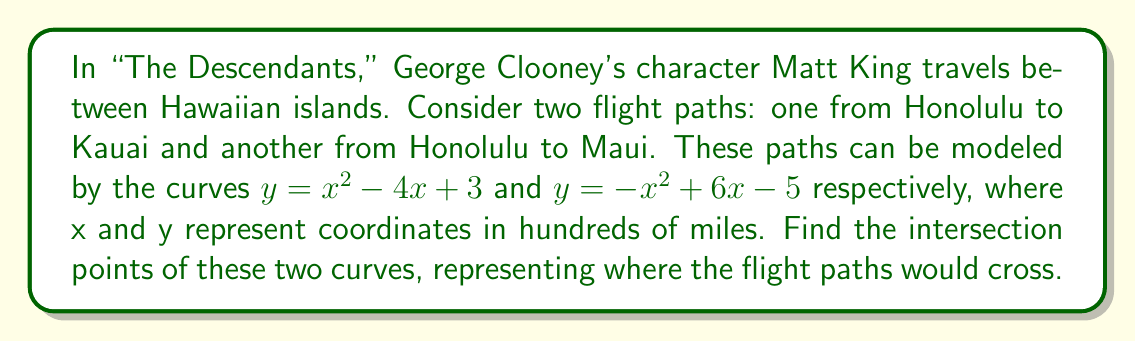Solve this math problem. 1) To find the intersection points, we need to solve the equation:
   $x^2 - 4x + 3 = -x^2 + 6x - 5$

2) Rearranging the equation:
   $x^2 - 4x + 3 + x^2 - 6x + 5 = 0$
   $2x^2 - 10x + 8 = 0$

3) Divide all terms by 2:
   $x^2 - 5x + 4 = 0$

4) This is a quadratic equation. We can solve it using the quadratic formula:
   $x = \frac{-b \pm \sqrt{b^2 - 4ac}}{2a}$

   Where $a = 1$, $b = -5$, and $c = 4$

5) Substituting these values:
   $x = \frac{5 \pm \sqrt{25 - 16}}{2} = \frac{5 \pm 3}{2}$

6) This gives us two solutions:
   $x_1 = \frac{5 + 3}{2} = 4$ and $x_2 = \frac{5 - 3}{2} = 1$

7) To find the y-coordinates, we can substitute these x-values into either of the original equations. Let's use $y = x^2 - 4x + 3$:

   For $x_1 = 4$: $y = 4^2 - 4(4) + 3 = 16 - 16 + 3 = 3$
   For $x_2 = 1$: $y = 1^2 - 4(1) + 3 = 1 - 4 + 3 = 0$

8) Therefore, the intersection points are (4, 3) and (1, 0).
Answer: (4, 3) and (1, 0) 